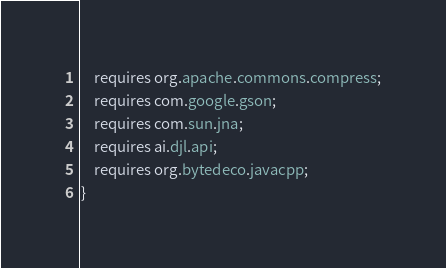Convert code to text. <code><loc_0><loc_0><loc_500><loc_500><_Java_>    requires org.apache.commons.compress;
    requires com.google.gson;
    requires com.sun.jna;
    requires ai.djl.api;
    requires org.bytedeco.javacpp;
}
</code> 